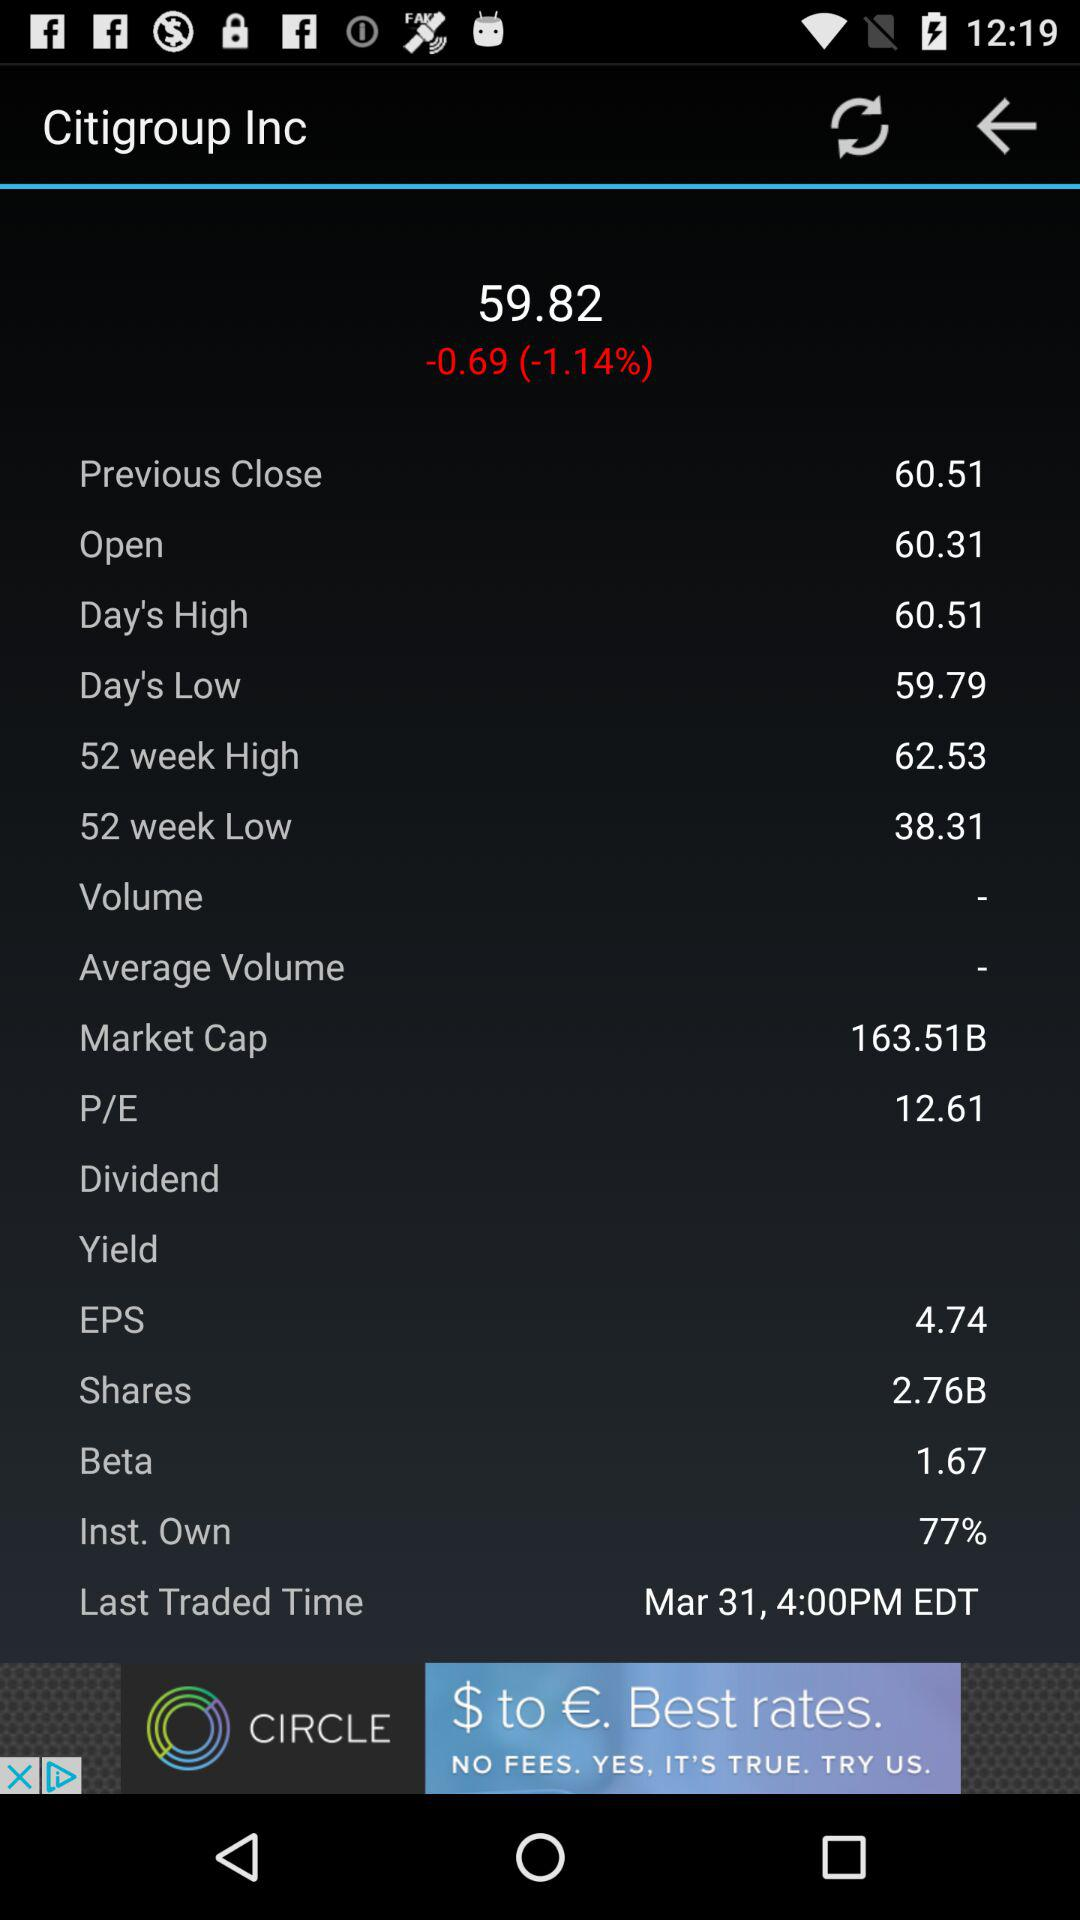What is the open value? The open value is 60.31. 